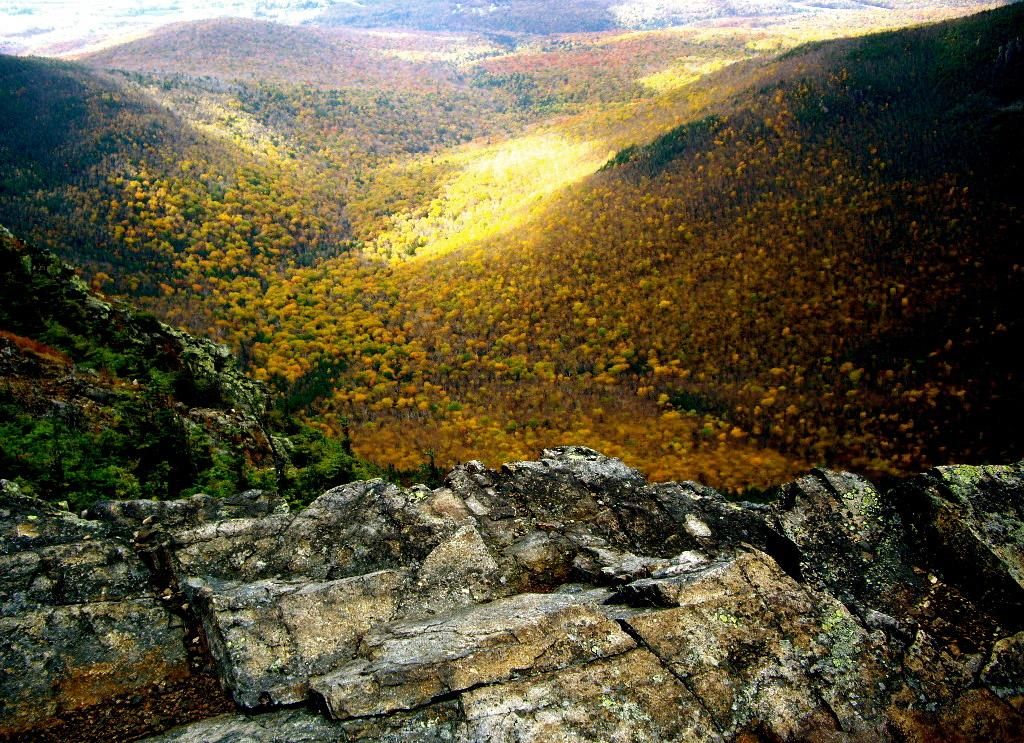What type of natural elements can be seen in the image? There are rocks, trees, and hills visible in the image. Can you describe the terrain in the image? The terrain in the image includes rocks, trees, and hills. What type of vegetation is present in the image? Trees are present in the image. What type of playground equipment can be seen in the image? There is no playground equipment present in the image; it features natural elements such as rocks, trees, and hills. What is the plot of the story depicted in the image? The image does not depict a story or plot; it is a representation of natural elements. 